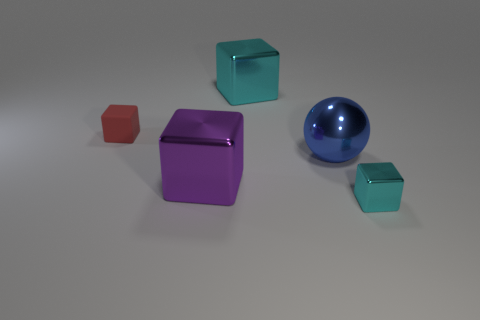How many objects are big purple shiny things right of the red rubber cube or tiny things that are in front of the red cube?
Your answer should be very brief. 2. Are there any things to the left of the cyan shiny block that is behind the red matte block?
Your answer should be compact. Yes. There is a metal thing that is the same size as the matte block; what is its shape?
Provide a short and direct response. Cube. How many objects are either tiny cubes behind the blue shiny ball or brown metallic things?
Give a very brief answer. 1. What number of other objects are the same material as the small cyan cube?
Your response must be concise. 3. The large thing that is the same color as the small metal thing is what shape?
Your response must be concise. Cube. What is the size of the cyan cube that is right of the large cyan cube?
Provide a succinct answer. Small. What shape is the big cyan thing that is made of the same material as the big blue object?
Give a very brief answer. Cube. Does the purple thing have the same material as the tiny cube that is behind the large sphere?
Your response must be concise. No. There is a small red rubber object in front of the large cyan cube; is it the same shape as the large cyan shiny object?
Give a very brief answer. Yes. 